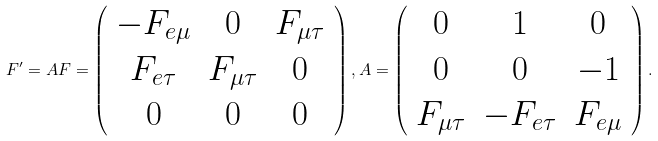Convert formula to latex. <formula><loc_0><loc_0><loc_500><loc_500>F ^ { \prime } = A F = \left ( \begin{array} { c c c } - F _ { e \mu } & 0 & F _ { \mu \tau } \\ F _ { e \tau } & F _ { \mu \tau } & 0 \\ 0 & 0 & 0 \\ \end{array} \right ) , A = \left ( \begin{array} { c c c } 0 & 1 & 0 \\ 0 & 0 & - 1 \\ F _ { \mu \tau } & - F _ { e \tau } & F _ { e \mu } \\ \end{array} \right ) .</formula> 